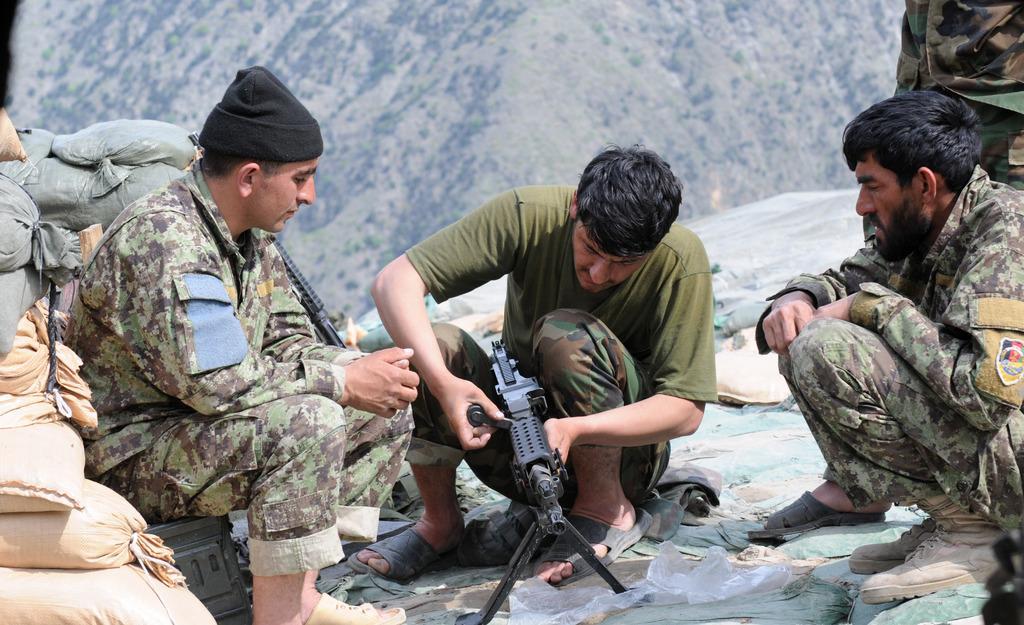Please provide a concise description of this image. In this picture, we see three men in the uniform are sitting. On the right side, we see a person in the uniform is standing. The man in the middle of the picture is holding a black color object in his hands. On the left side, we see the bags in cream and grey color. There are trees and hills in the background. 